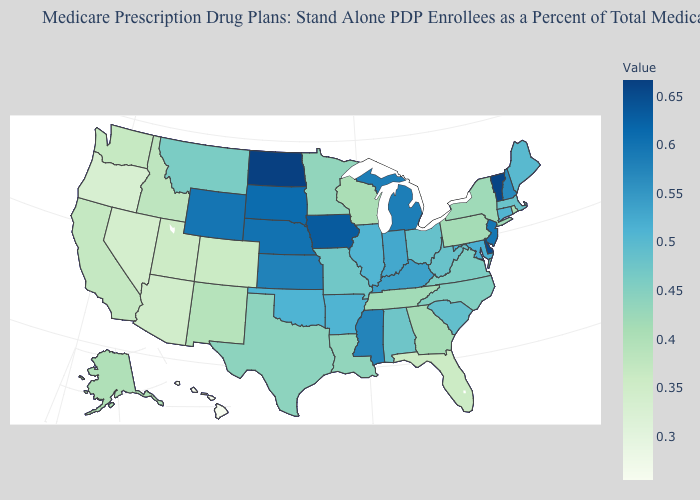Does Hawaii have the lowest value in the West?
Be succinct. Yes. Does Florida have a higher value than Hawaii?
Quick response, please. Yes. Among the states that border Vermont , which have the lowest value?
Quick response, please. New York. Is the legend a continuous bar?
Give a very brief answer. Yes. Does the map have missing data?
Be succinct. No. Does Pennsylvania have the lowest value in the USA?
Answer briefly. No. Among the states that border Illinois , does Wisconsin have the highest value?
Give a very brief answer. No. Which states have the highest value in the USA?
Write a very short answer. North Dakota. Does Montana have a lower value than Delaware?
Answer briefly. Yes. 